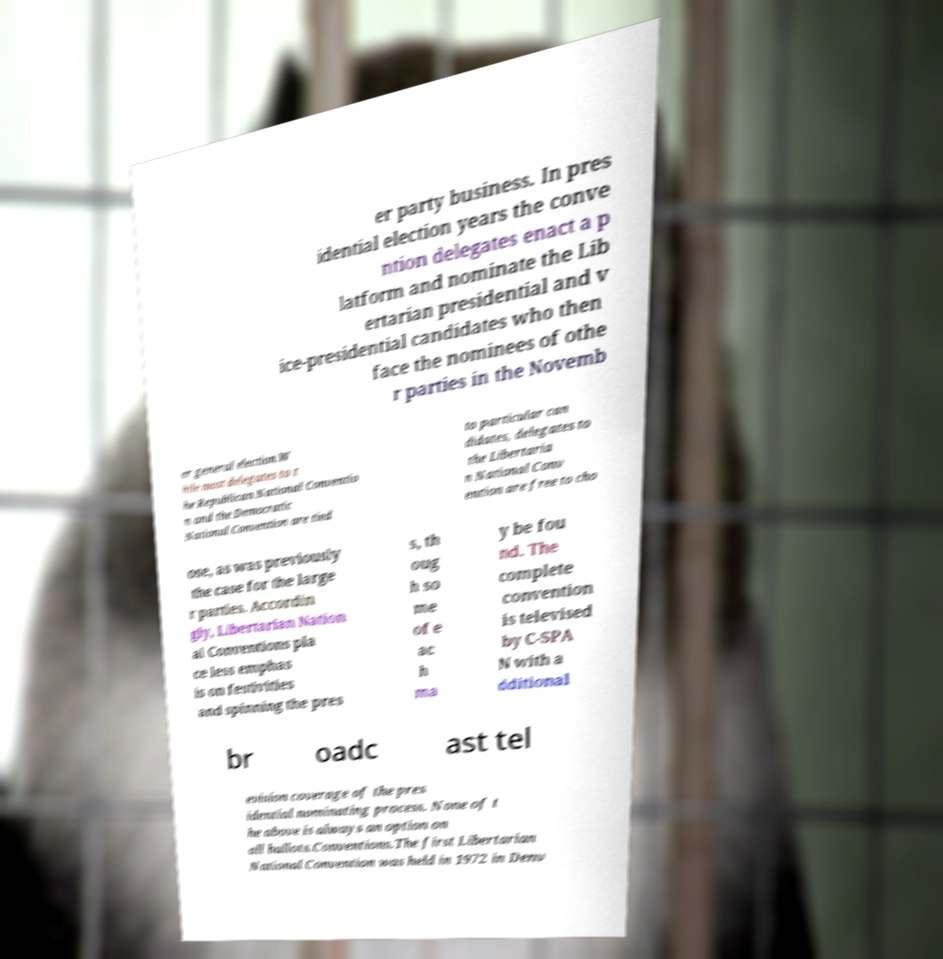What messages or text are displayed in this image? I need them in a readable, typed format. er party business. In pres idential election years the conve ntion delegates enact a p latform and nominate the Lib ertarian presidential and v ice-presidential candidates who then face the nominees of othe r parties in the Novemb er general election.W hile most delegates to t he Republican National Conventio n and the Democratic National Convention are tied to particular can didates, delegates to the Libertaria n National Conv ention are free to cho ose, as was previously the case for the large r parties. Accordin gly, Libertarian Nation al Conventions pla ce less emphas is on festivities and spinning the pres s, th oug h so me of e ac h ma y be fou nd. The complete convention is televised by C-SPA N with a dditional br oadc ast tel evision coverage of the pres idential nominating process. None of t he above is always an option on all ballots.Conventions.The first Libertarian National Convention was held in 1972 in Denv 